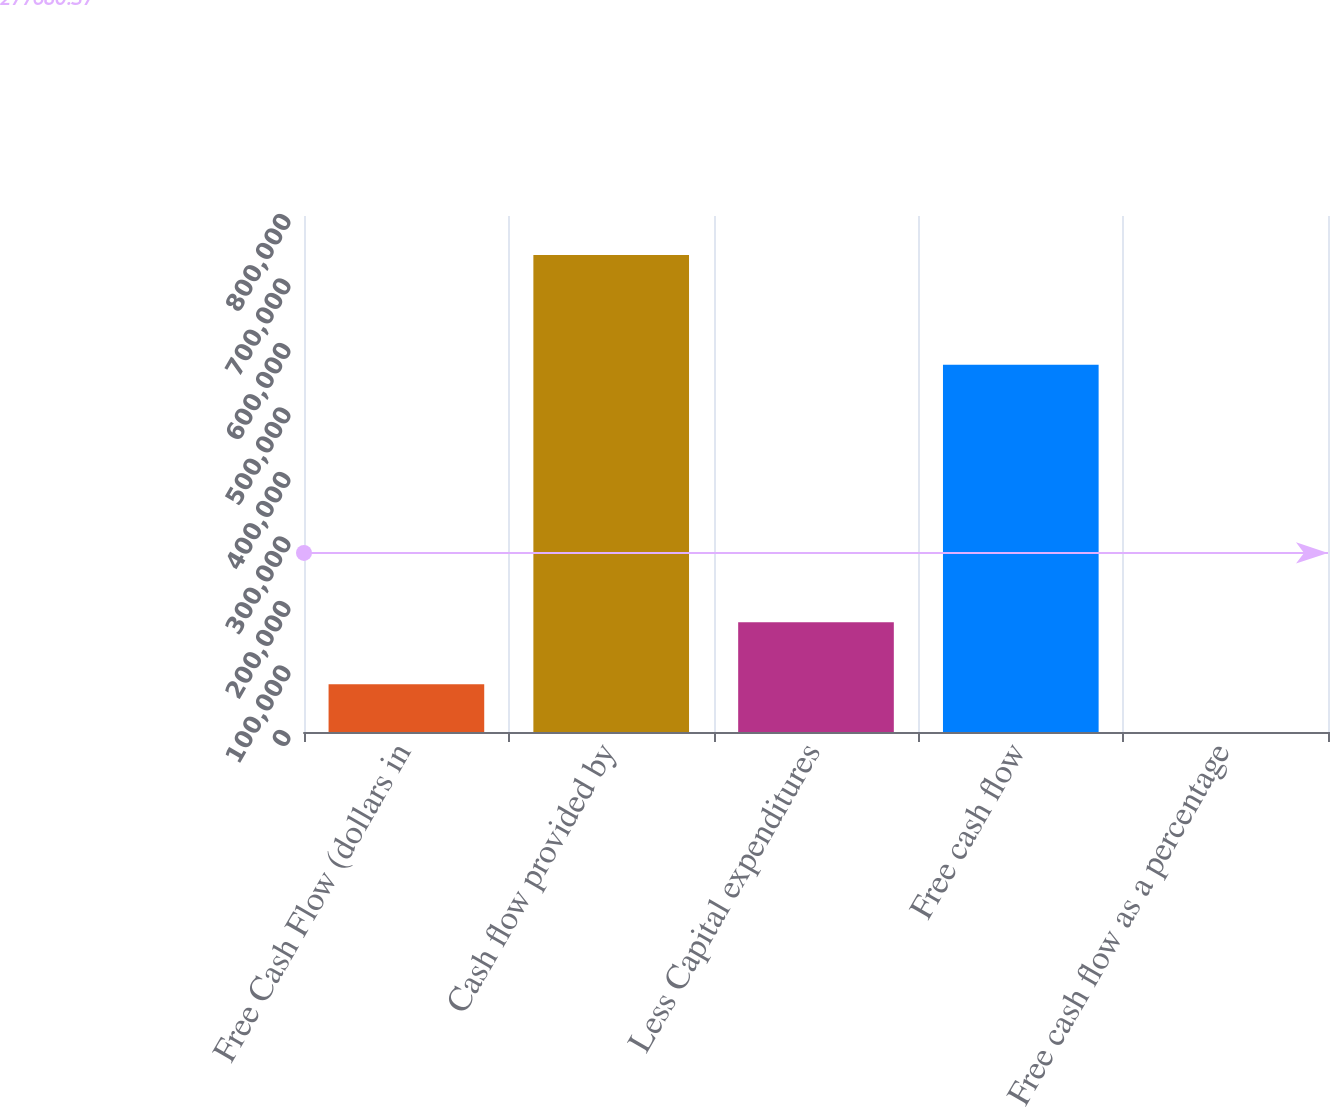<chart> <loc_0><loc_0><loc_500><loc_500><bar_chart><fcel>Free Cash Flow (dollars in<fcel>Cash flow provided by<fcel>Less Capital expenditures<fcel>Free cash flow<fcel>Free cash flow as a percentage<nl><fcel>73948.4<fcel>739409<fcel>170068<fcel>569341<fcel>8.3<nl></chart> 